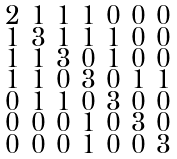<formula> <loc_0><loc_0><loc_500><loc_500>\begin{smallmatrix} 2 & 1 & 1 & 1 & 0 & 0 & 0 \\ 1 & 3 & 1 & 1 & 1 & 0 & 0 \\ 1 & 1 & 3 & 0 & 1 & 0 & 0 \\ 1 & 1 & 0 & 3 & 0 & 1 & 1 \\ 0 & 1 & 1 & 0 & 3 & 0 & 0 \\ 0 & 0 & 0 & 1 & 0 & 3 & 0 \\ 0 & 0 & 0 & 1 & 0 & 0 & 3 \end{smallmatrix}</formula> 